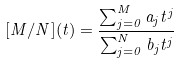Convert formula to latex. <formula><loc_0><loc_0><loc_500><loc_500>[ M / N ] ( t ) = \frac { \sum _ { j = 0 } ^ { M } a _ { j } t ^ { j } } { \sum _ { j = 0 } ^ { N } b _ { j } t ^ { j } }</formula> 